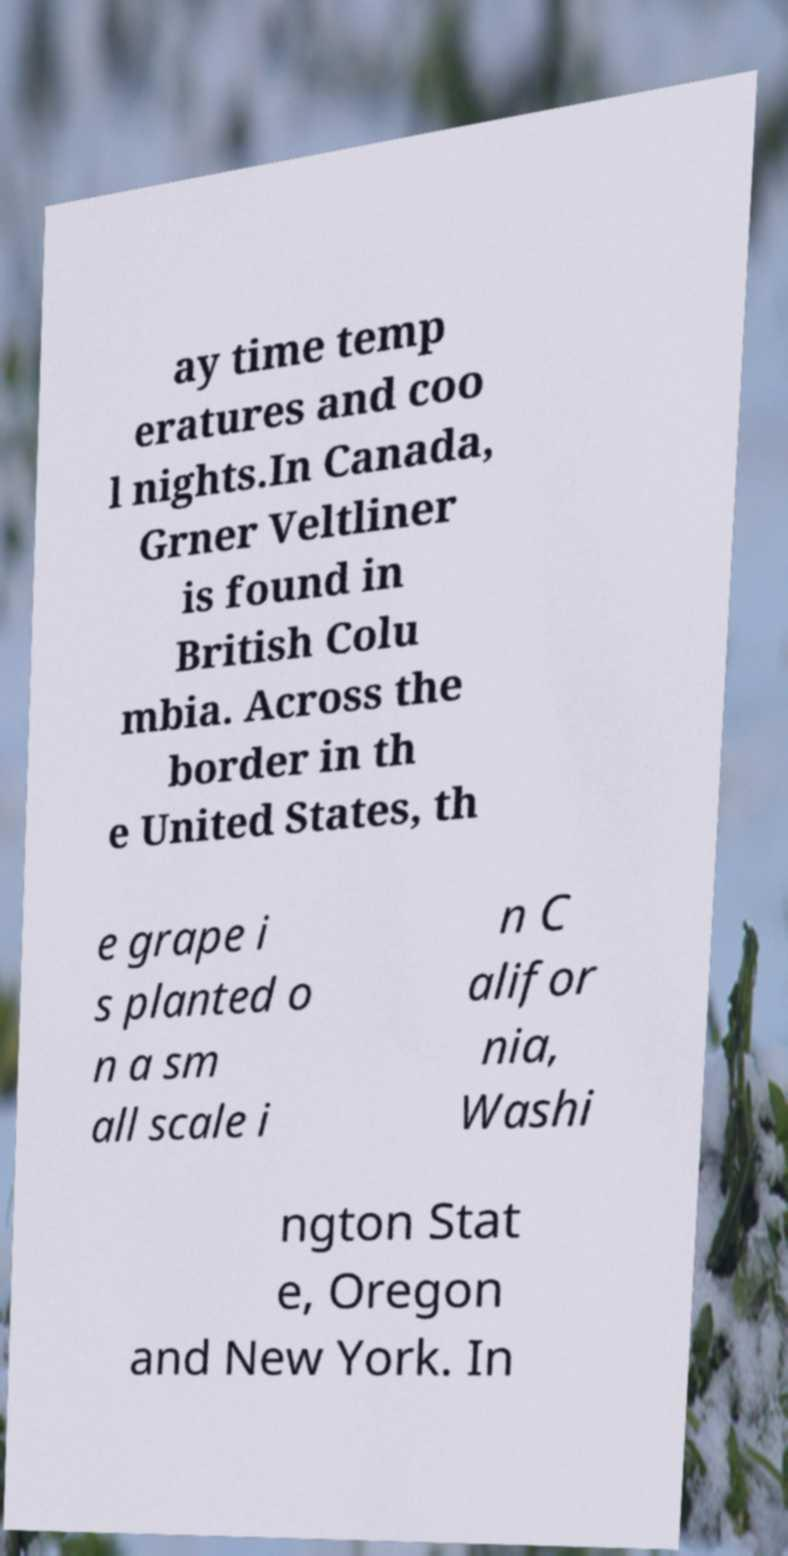Could you assist in decoding the text presented in this image and type it out clearly? ay time temp eratures and coo l nights.In Canada, Grner Veltliner is found in British Colu mbia. Across the border in th e United States, th e grape i s planted o n a sm all scale i n C alifor nia, Washi ngton Stat e, Oregon and New York. In 